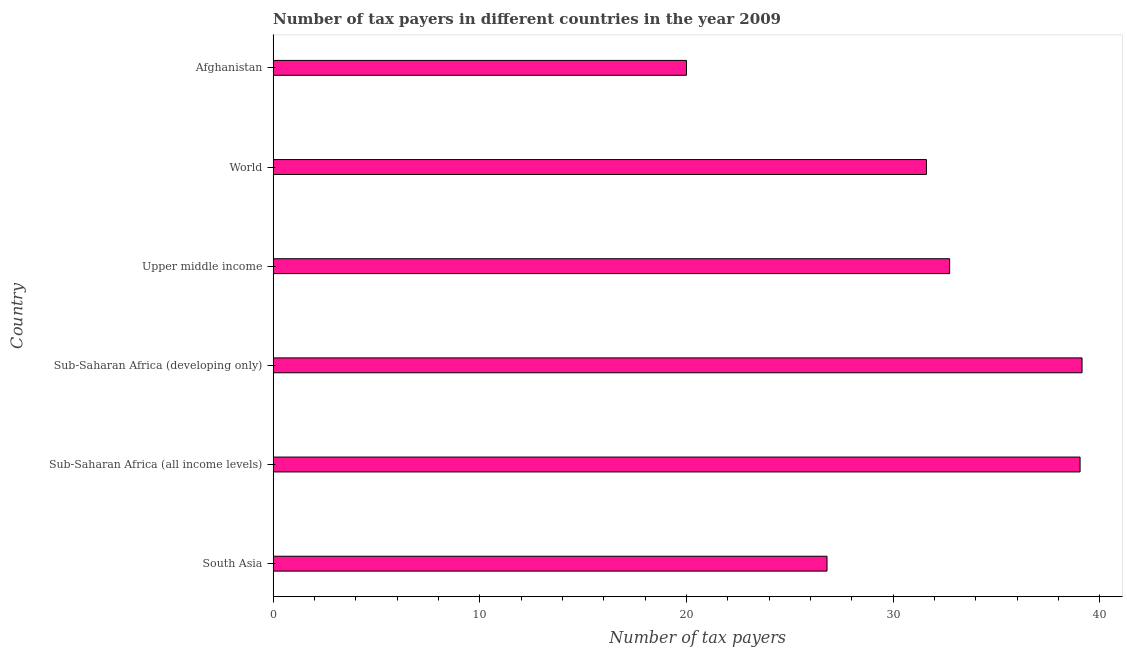Does the graph contain grids?
Give a very brief answer. No. What is the title of the graph?
Make the answer very short. Number of tax payers in different countries in the year 2009. What is the label or title of the X-axis?
Keep it short and to the point. Number of tax payers. Across all countries, what is the maximum number of tax payers?
Your response must be concise. 39.14. Across all countries, what is the minimum number of tax payers?
Give a very brief answer. 20. In which country was the number of tax payers maximum?
Your response must be concise. Sub-Saharan Africa (developing only). In which country was the number of tax payers minimum?
Your answer should be compact. Afghanistan. What is the sum of the number of tax payers?
Ensure brevity in your answer.  189.33. What is the difference between the number of tax payers in Sub-Saharan Africa (all income levels) and Sub-Saharan Africa (developing only)?
Ensure brevity in your answer.  -0.1. What is the average number of tax payers per country?
Make the answer very short. 31.55. What is the median number of tax payers?
Your answer should be compact. 32.17. What is the ratio of the number of tax payers in Upper middle income to that in World?
Keep it short and to the point. 1.04. Is the number of tax payers in Sub-Saharan Africa (all income levels) less than that in World?
Your answer should be compact. No. What is the difference between the highest and the second highest number of tax payers?
Provide a succinct answer. 0.1. What is the difference between the highest and the lowest number of tax payers?
Offer a terse response. 19.14. How many bars are there?
Provide a succinct answer. 6. Are all the bars in the graph horizontal?
Offer a terse response. Yes. How many countries are there in the graph?
Provide a short and direct response. 6. What is the difference between two consecutive major ticks on the X-axis?
Offer a very short reply. 10. What is the Number of tax payers in South Asia?
Your answer should be very brief. 26.8. What is the Number of tax payers in Sub-Saharan Africa (all income levels)?
Give a very brief answer. 39.04. What is the Number of tax payers in Sub-Saharan Africa (developing only)?
Ensure brevity in your answer.  39.14. What is the Number of tax payers in Upper middle income?
Provide a short and direct response. 32.73. What is the Number of tax payers of World?
Offer a terse response. 31.61. What is the Number of tax payers of Afghanistan?
Offer a very short reply. 20. What is the difference between the Number of tax payers in South Asia and Sub-Saharan Africa (all income levels)?
Keep it short and to the point. -12.24. What is the difference between the Number of tax payers in South Asia and Sub-Saharan Africa (developing only)?
Ensure brevity in your answer.  -12.34. What is the difference between the Number of tax payers in South Asia and Upper middle income?
Your answer should be very brief. -5.93. What is the difference between the Number of tax payers in South Asia and World?
Offer a very short reply. -4.81. What is the difference between the Number of tax payers in South Asia and Afghanistan?
Provide a succinct answer. 6.8. What is the difference between the Number of tax payers in Sub-Saharan Africa (all income levels) and Sub-Saharan Africa (developing only)?
Offer a very short reply. -0.1. What is the difference between the Number of tax payers in Sub-Saharan Africa (all income levels) and Upper middle income?
Ensure brevity in your answer.  6.31. What is the difference between the Number of tax payers in Sub-Saharan Africa (all income levels) and World?
Keep it short and to the point. 7.43. What is the difference between the Number of tax payers in Sub-Saharan Africa (all income levels) and Afghanistan?
Your answer should be very brief. 19.04. What is the difference between the Number of tax payers in Sub-Saharan Africa (developing only) and Upper middle income?
Provide a succinct answer. 6.41. What is the difference between the Number of tax payers in Sub-Saharan Africa (developing only) and World?
Ensure brevity in your answer.  7.53. What is the difference between the Number of tax payers in Sub-Saharan Africa (developing only) and Afghanistan?
Ensure brevity in your answer.  19.14. What is the difference between the Number of tax payers in Upper middle income and World?
Your answer should be very brief. 1.12. What is the difference between the Number of tax payers in Upper middle income and Afghanistan?
Provide a succinct answer. 12.73. What is the difference between the Number of tax payers in World and Afghanistan?
Provide a short and direct response. 11.61. What is the ratio of the Number of tax payers in South Asia to that in Sub-Saharan Africa (all income levels)?
Provide a short and direct response. 0.69. What is the ratio of the Number of tax payers in South Asia to that in Sub-Saharan Africa (developing only)?
Your answer should be very brief. 0.69. What is the ratio of the Number of tax payers in South Asia to that in Upper middle income?
Your answer should be very brief. 0.82. What is the ratio of the Number of tax payers in South Asia to that in World?
Make the answer very short. 0.85. What is the ratio of the Number of tax payers in South Asia to that in Afghanistan?
Provide a succinct answer. 1.34. What is the ratio of the Number of tax payers in Sub-Saharan Africa (all income levels) to that in Sub-Saharan Africa (developing only)?
Provide a short and direct response. 1. What is the ratio of the Number of tax payers in Sub-Saharan Africa (all income levels) to that in Upper middle income?
Provide a short and direct response. 1.19. What is the ratio of the Number of tax payers in Sub-Saharan Africa (all income levels) to that in World?
Your answer should be compact. 1.24. What is the ratio of the Number of tax payers in Sub-Saharan Africa (all income levels) to that in Afghanistan?
Offer a very short reply. 1.95. What is the ratio of the Number of tax payers in Sub-Saharan Africa (developing only) to that in Upper middle income?
Make the answer very short. 1.2. What is the ratio of the Number of tax payers in Sub-Saharan Africa (developing only) to that in World?
Ensure brevity in your answer.  1.24. What is the ratio of the Number of tax payers in Sub-Saharan Africa (developing only) to that in Afghanistan?
Offer a very short reply. 1.96. What is the ratio of the Number of tax payers in Upper middle income to that in World?
Your answer should be very brief. 1.04. What is the ratio of the Number of tax payers in Upper middle income to that in Afghanistan?
Your answer should be compact. 1.64. What is the ratio of the Number of tax payers in World to that in Afghanistan?
Your response must be concise. 1.58. 